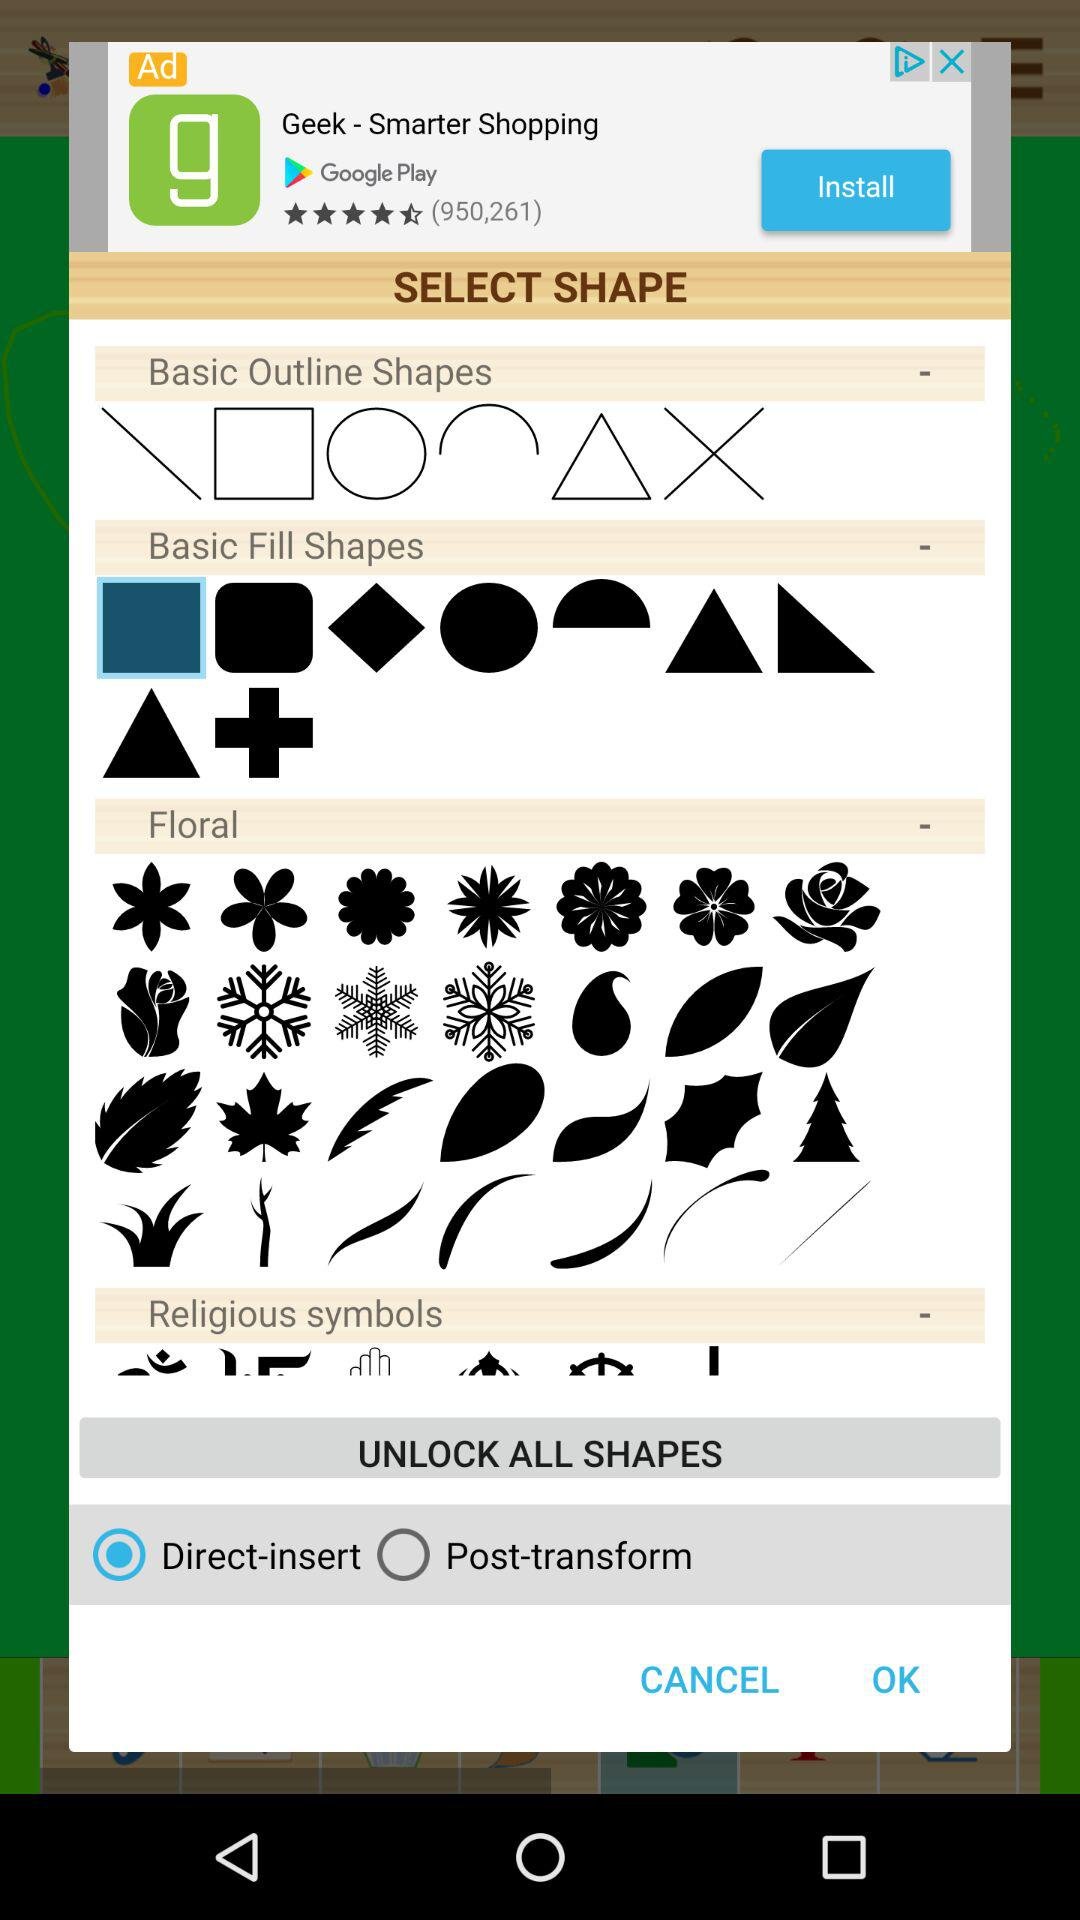Which option is selected? The selected option is "Direct-insert". 